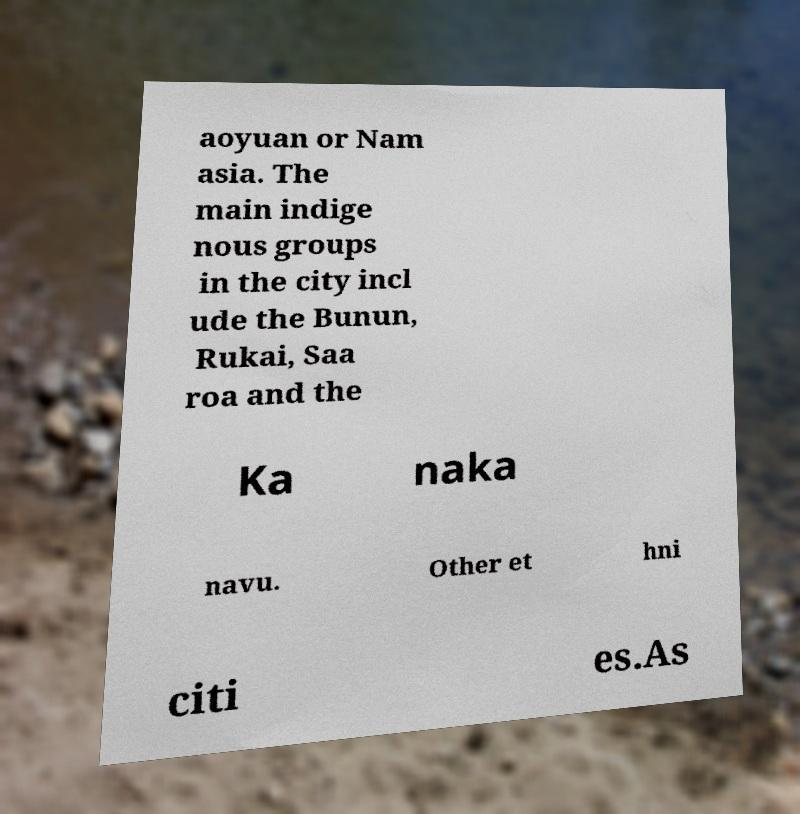Please read and relay the text visible in this image. What does it say? aoyuan or Nam asia. The main indige nous groups in the city incl ude the Bunun, Rukai, Saa roa and the Ka naka navu. Other et hni citi es.As 